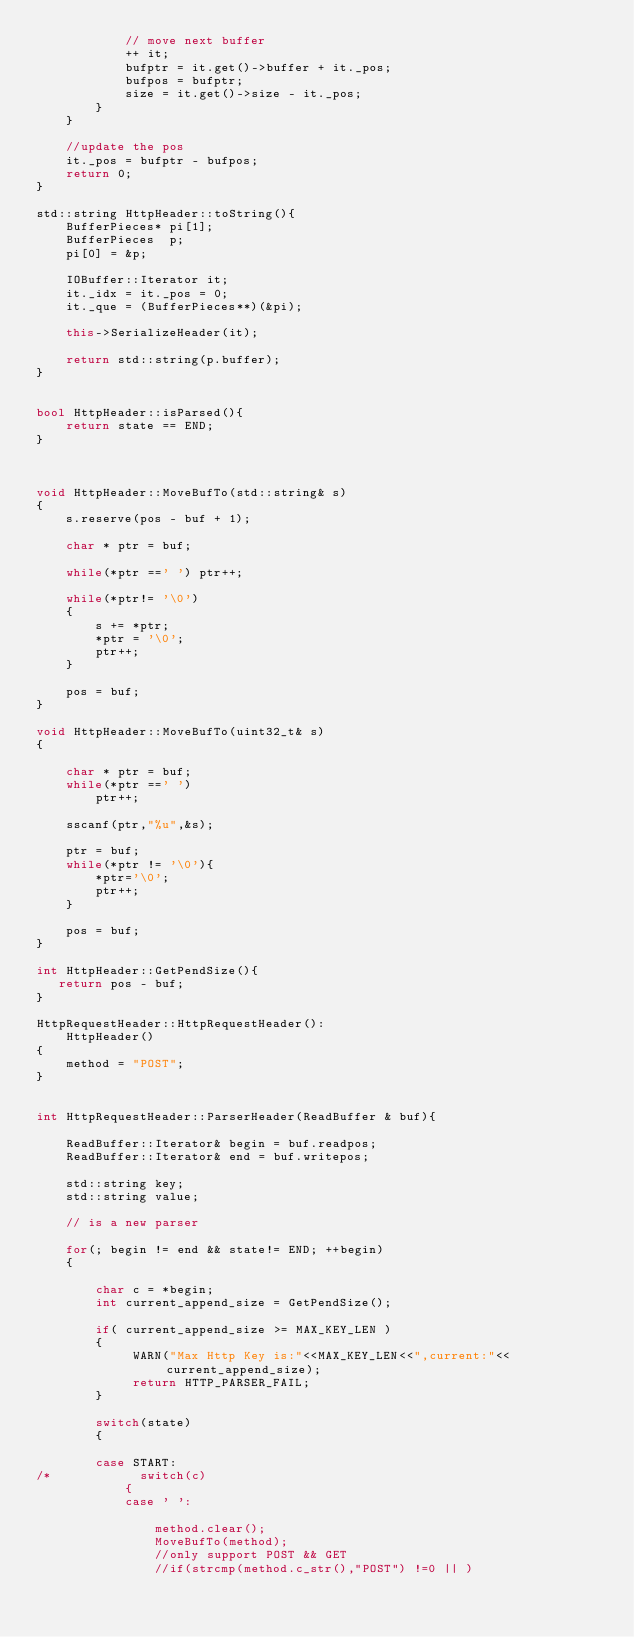Convert code to text. <code><loc_0><loc_0><loc_500><loc_500><_C++_>            // move next buffer
            ++ it;
            bufptr = it.get()->buffer + it._pos;
            bufpos = bufptr;
            size = it.get()->size - it._pos;
        }
    }

    //update the pos
    it._pos = bufptr - bufpos;
    return 0;
}

std::string HttpHeader::toString(){
    BufferPieces* pi[1];
    BufferPieces  p;
    pi[0] = &p;

    IOBuffer::Iterator it;
    it._idx = it._pos = 0;
    it._que = (BufferPieces**)(&pi);

    this->SerializeHeader(it);

    return std::string(p.buffer);
}


bool HttpHeader::isParsed(){
    return state == END;
}



void HttpHeader::MoveBufTo(std::string& s)
{
    s.reserve(pos - buf + 1);

    char * ptr = buf;

    while(*ptr ==' ') ptr++;

    while(*ptr!= '\0')
    {
        s += *ptr;
        *ptr = '\0';
        ptr++;
    }

    pos = buf;
}

void HttpHeader::MoveBufTo(uint32_t& s)
{

    char * ptr = buf;
    while(*ptr ==' ')
        ptr++;

    sscanf(ptr,"%u",&s);

    ptr = buf;
    while(*ptr != '\0'){
        *ptr='\0';
        ptr++;
    }

    pos = buf;
}

int HttpHeader::GetPendSize(){
   return pos - buf;
}

HttpRequestHeader::HttpRequestHeader():
    HttpHeader()
{
    method = "POST";
}


int HttpRequestHeader::ParserHeader(ReadBuffer & buf){

    ReadBuffer::Iterator& begin = buf.readpos;
    ReadBuffer::Iterator& end = buf.writepos;

    std::string key;
    std::string value;

    // is a new parser

    for(; begin != end && state!= END; ++begin)
    {

        char c = *begin;
        int current_append_size = GetPendSize();
        
        if( current_append_size >= MAX_KEY_LEN )
        {
             WARN("Max Http Key is:"<<MAX_KEY_LEN<<",current:"<<current_append_size);
             return HTTP_PARSER_FAIL;
        }
        
        switch(state)
        {

        case START:
/*            switch(c)
            {
            case ' ':

                method.clear();
                MoveBufTo(method);
                //only support POST && GET
                //if(strcmp(method.c_str(),"POST") !=0 || )</code> 